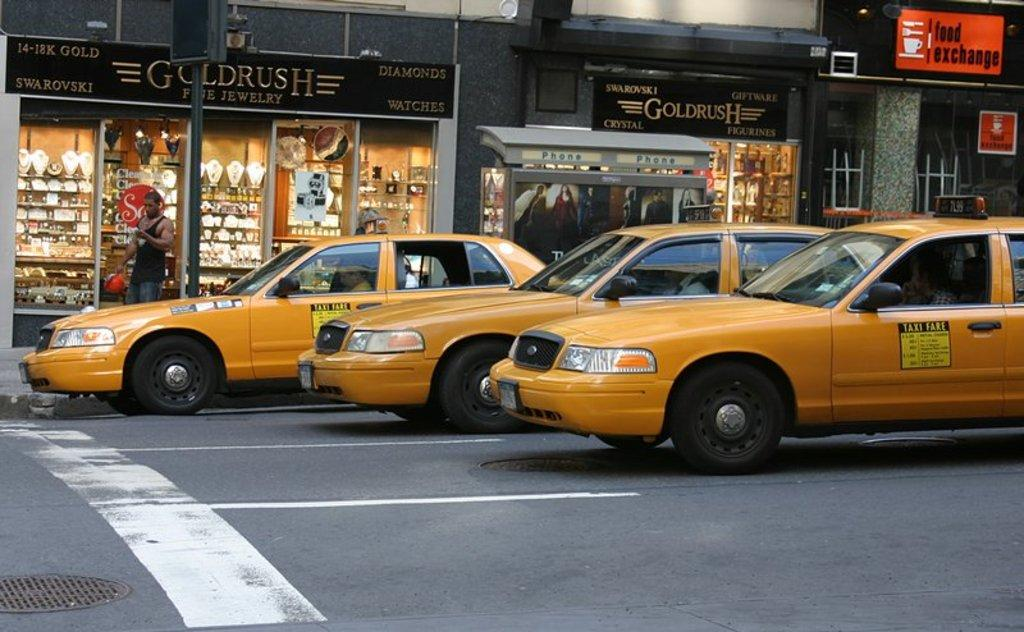<image>
Give a short and clear explanation of the subsequent image. taxis in fron of a store front named Goldrush 